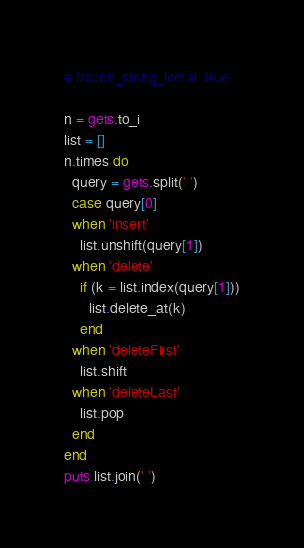Convert code to text. <code><loc_0><loc_0><loc_500><loc_500><_Ruby_># frozen_string_literal: true

n = gets.to_i
list = []
n.times do
  query = gets.split(' ')
  case query[0]
  when 'insert'
    list.unshift(query[1])
  when 'delete'
    if (k = list.index(query[1]))
      list.delete_at(k)
    end
  when 'deleteFirst'
    list.shift
  when 'deleteLast'
    list.pop
  end
end
puts list.join(' ')

</code> 